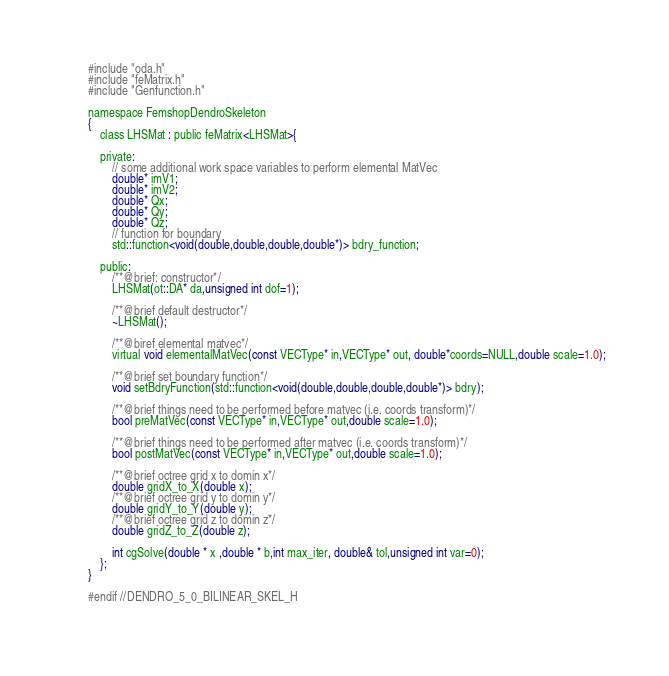Convert code to text. <code><loc_0><loc_0><loc_500><loc_500><_C_>
    #include "oda.h"
    #include "feMatrix.h"
    #include "Genfunction.h"

    namespace FemshopDendroSkeleton
    {
        class LHSMat : public feMatrix<LHSMat>{

        private:
            // some additional work space variables to perform elemental MatVec
            double* imV1;
            double* imV2;
            double* Qx;
            double* Qy;
            double* Qz;
            // function for boundary
	        std::function<void(double,double,double,double*)> bdry_function;

        public:
            /**@brief: constructor*/
            LHSMat(ot::DA* da,unsigned int dof=1);

            /**@brief default destructor*/
            ~LHSMat();

            /**@biref elemental matvec*/
            virtual void elementalMatVec(const VECType* in,VECType* out, double*coords=NULL,double scale=1.0);
            
            /**@brief set boundary function*/	
            void setBdryFunction(std::function<void(double,double,double,double*)> bdry);
            
            /**@brief things need to be performed before matvec (i.e. coords transform)*/
            bool preMatVec(const VECType* in,VECType* out,double scale=1.0);

            /**@brief things need to be performed after matvec (i.e. coords transform)*/
            bool postMatVec(const VECType* in,VECType* out,double scale=1.0);

            /**@brief octree grid x to domin x*/
            double gridX_to_X(double x);
            /**@brief octree grid y to domin y*/
            double gridY_to_Y(double y);
            /**@brief octree grid z to domin z*/
            double gridZ_to_Z(double z);

            int cgSolve(double * x ,double * b,int max_iter, double& tol,unsigned int var=0);
        };
    }

    #endif //DENDRO_5_0_BILINEAR_SKEL_H
    </code> 